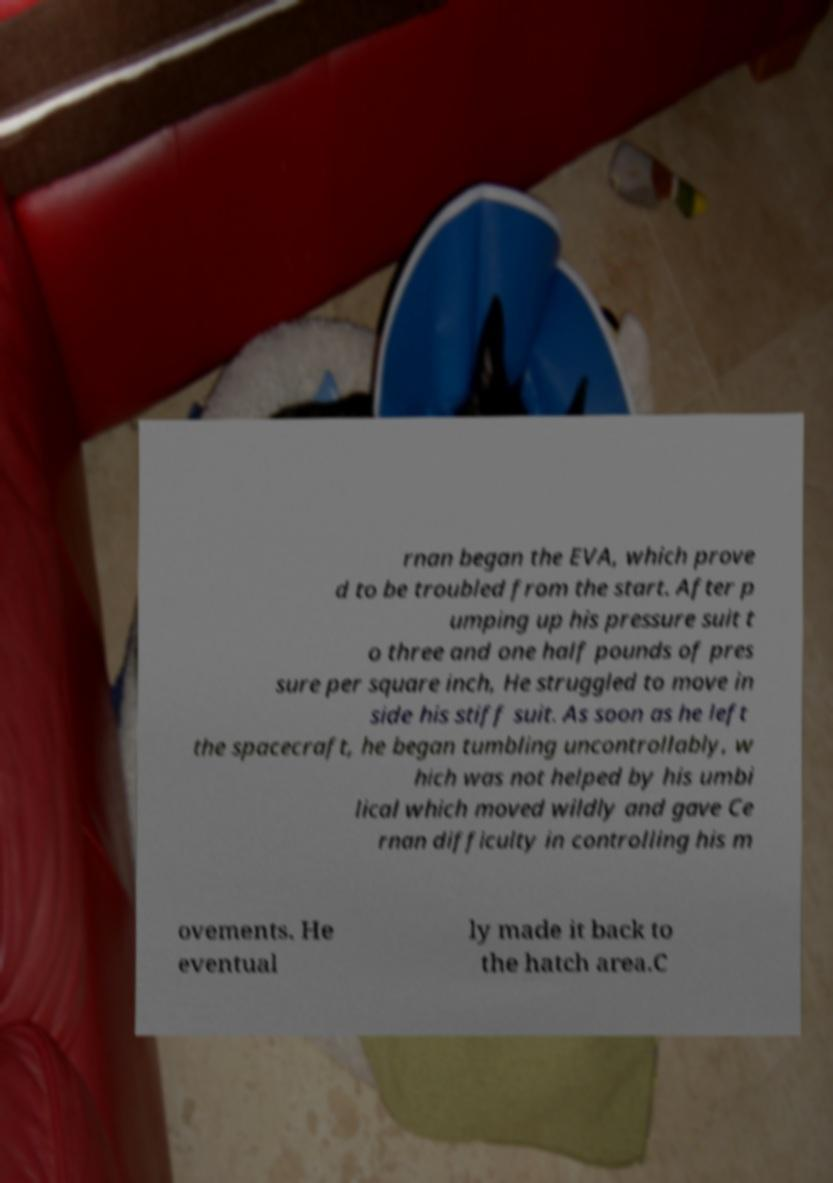I need the written content from this picture converted into text. Can you do that? rnan began the EVA, which prove d to be troubled from the start. After p umping up his pressure suit t o three and one half pounds of pres sure per square inch, He struggled to move in side his stiff suit. As soon as he left the spacecraft, he began tumbling uncontrollably, w hich was not helped by his umbi lical which moved wildly and gave Ce rnan difficulty in controlling his m ovements. He eventual ly made it back to the hatch area.C 